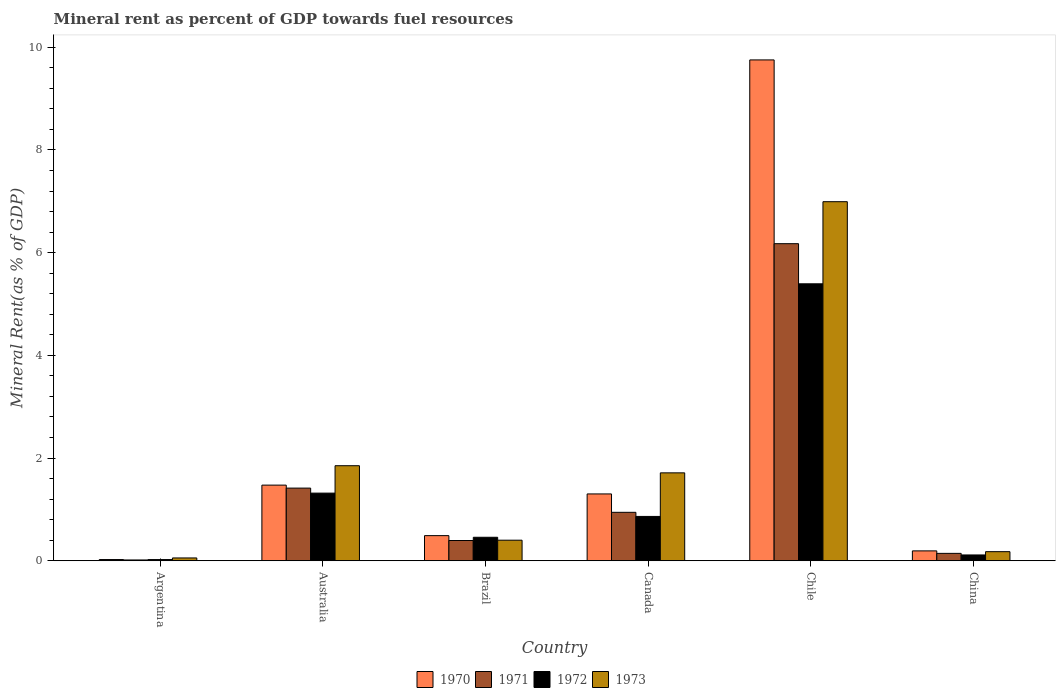Are the number of bars on each tick of the X-axis equal?
Make the answer very short. Yes. How many bars are there on the 2nd tick from the right?
Offer a terse response. 4. In how many cases, is the number of bars for a given country not equal to the number of legend labels?
Make the answer very short. 0. What is the mineral rent in 1971 in Australia?
Offer a very short reply. 1.42. Across all countries, what is the maximum mineral rent in 1972?
Keep it short and to the point. 5.39. Across all countries, what is the minimum mineral rent in 1970?
Your answer should be compact. 0.02. In which country was the mineral rent in 1972 maximum?
Provide a succinct answer. Chile. What is the total mineral rent in 1972 in the graph?
Your response must be concise. 8.17. What is the difference between the mineral rent in 1971 in Brazil and that in China?
Your answer should be compact. 0.25. What is the difference between the mineral rent in 1973 in Canada and the mineral rent in 1972 in Chile?
Give a very brief answer. -3.68. What is the average mineral rent in 1970 per country?
Ensure brevity in your answer.  2.21. What is the difference between the mineral rent of/in 1970 and mineral rent of/in 1973 in Chile?
Your answer should be compact. 2.76. In how many countries, is the mineral rent in 1971 greater than 8 %?
Give a very brief answer. 0. What is the ratio of the mineral rent in 1970 in Argentina to that in China?
Offer a terse response. 0.12. Is the mineral rent in 1970 in Australia less than that in Chile?
Your answer should be compact. Yes. What is the difference between the highest and the second highest mineral rent in 1973?
Provide a succinct answer. 0.14. What is the difference between the highest and the lowest mineral rent in 1971?
Make the answer very short. 6.16. In how many countries, is the mineral rent in 1972 greater than the average mineral rent in 1972 taken over all countries?
Make the answer very short. 1. Is the sum of the mineral rent in 1971 in Brazil and Chile greater than the maximum mineral rent in 1970 across all countries?
Make the answer very short. No. Is it the case that in every country, the sum of the mineral rent in 1973 and mineral rent in 1971 is greater than the sum of mineral rent in 1972 and mineral rent in 1970?
Your answer should be compact. No. What does the 3rd bar from the left in Canada represents?
Provide a short and direct response. 1972. Are all the bars in the graph horizontal?
Your answer should be compact. No. How many countries are there in the graph?
Offer a very short reply. 6. What is the difference between two consecutive major ticks on the Y-axis?
Your response must be concise. 2. Does the graph contain any zero values?
Ensure brevity in your answer.  No. Does the graph contain grids?
Offer a very short reply. No. Where does the legend appear in the graph?
Offer a terse response. Bottom center. What is the title of the graph?
Provide a succinct answer. Mineral rent as percent of GDP towards fuel resources. What is the label or title of the Y-axis?
Make the answer very short. Mineral Rent(as % of GDP). What is the Mineral Rent(as % of GDP) in 1970 in Argentina?
Give a very brief answer. 0.02. What is the Mineral Rent(as % of GDP) of 1971 in Argentina?
Offer a terse response. 0.02. What is the Mineral Rent(as % of GDP) of 1972 in Argentina?
Provide a succinct answer. 0.02. What is the Mineral Rent(as % of GDP) of 1973 in Argentina?
Provide a short and direct response. 0.06. What is the Mineral Rent(as % of GDP) in 1970 in Australia?
Offer a very short reply. 1.47. What is the Mineral Rent(as % of GDP) in 1971 in Australia?
Your answer should be compact. 1.42. What is the Mineral Rent(as % of GDP) of 1972 in Australia?
Give a very brief answer. 1.32. What is the Mineral Rent(as % of GDP) of 1973 in Australia?
Offer a terse response. 1.85. What is the Mineral Rent(as % of GDP) of 1970 in Brazil?
Your answer should be very brief. 0.49. What is the Mineral Rent(as % of GDP) of 1971 in Brazil?
Keep it short and to the point. 0.39. What is the Mineral Rent(as % of GDP) in 1972 in Brazil?
Make the answer very short. 0.46. What is the Mineral Rent(as % of GDP) in 1973 in Brazil?
Your response must be concise. 0.4. What is the Mineral Rent(as % of GDP) of 1970 in Canada?
Ensure brevity in your answer.  1.3. What is the Mineral Rent(as % of GDP) in 1971 in Canada?
Provide a short and direct response. 0.94. What is the Mineral Rent(as % of GDP) of 1972 in Canada?
Your response must be concise. 0.86. What is the Mineral Rent(as % of GDP) of 1973 in Canada?
Your answer should be compact. 1.71. What is the Mineral Rent(as % of GDP) of 1970 in Chile?
Offer a very short reply. 9.75. What is the Mineral Rent(as % of GDP) of 1971 in Chile?
Offer a very short reply. 6.18. What is the Mineral Rent(as % of GDP) in 1972 in Chile?
Keep it short and to the point. 5.39. What is the Mineral Rent(as % of GDP) of 1973 in Chile?
Offer a very short reply. 6.99. What is the Mineral Rent(as % of GDP) in 1970 in China?
Provide a short and direct response. 0.19. What is the Mineral Rent(as % of GDP) of 1971 in China?
Your answer should be very brief. 0.14. What is the Mineral Rent(as % of GDP) in 1972 in China?
Offer a very short reply. 0.11. What is the Mineral Rent(as % of GDP) of 1973 in China?
Give a very brief answer. 0.18. Across all countries, what is the maximum Mineral Rent(as % of GDP) of 1970?
Provide a short and direct response. 9.75. Across all countries, what is the maximum Mineral Rent(as % of GDP) in 1971?
Offer a very short reply. 6.18. Across all countries, what is the maximum Mineral Rent(as % of GDP) of 1972?
Give a very brief answer. 5.39. Across all countries, what is the maximum Mineral Rent(as % of GDP) of 1973?
Your answer should be very brief. 6.99. Across all countries, what is the minimum Mineral Rent(as % of GDP) of 1970?
Offer a very short reply. 0.02. Across all countries, what is the minimum Mineral Rent(as % of GDP) of 1971?
Give a very brief answer. 0.02. Across all countries, what is the minimum Mineral Rent(as % of GDP) in 1972?
Provide a succinct answer. 0.02. Across all countries, what is the minimum Mineral Rent(as % of GDP) in 1973?
Provide a succinct answer. 0.06. What is the total Mineral Rent(as % of GDP) in 1970 in the graph?
Offer a very short reply. 13.24. What is the total Mineral Rent(as % of GDP) in 1971 in the graph?
Make the answer very short. 9.09. What is the total Mineral Rent(as % of GDP) of 1972 in the graph?
Offer a terse response. 8.17. What is the total Mineral Rent(as % of GDP) of 1973 in the graph?
Keep it short and to the point. 11.19. What is the difference between the Mineral Rent(as % of GDP) of 1970 in Argentina and that in Australia?
Your answer should be compact. -1.45. What is the difference between the Mineral Rent(as % of GDP) in 1971 in Argentina and that in Australia?
Your response must be concise. -1.4. What is the difference between the Mineral Rent(as % of GDP) of 1972 in Argentina and that in Australia?
Provide a succinct answer. -1.29. What is the difference between the Mineral Rent(as % of GDP) of 1973 in Argentina and that in Australia?
Your answer should be very brief. -1.8. What is the difference between the Mineral Rent(as % of GDP) of 1970 in Argentina and that in Brazil?
Provide a succinct answer. -0.47. What is the difference between the Mineral Rent(as % of GDP) in 1971 in Argentina and that in Brazil?
Your answer should be very brief. -0.38. What is the difference between the Mineral Rent(as % of GDP) in 1972 in Argentina and that in Brazil?
Offer a very short reply. -0.43. What is the difference between the Mineral Rent(as % of GDP) in 1973 in Argentina and that in Brazil?
Your response must be concise. -0.35. What is the difference between the Mineral Rent(as % of GDP) in 1970 in Argentina and that in Canada?
Ensure brevity in your answer.  -1.28. What is the difference between the Mineral Rent(as % of GDP) in 1971 in Argentina and that in Canada?
Ensure brevity in your answer.  -0.93. What is the difference between the Mineral Rent(as % of GDP) of 1972 in Argentina and that in Canada?
Keep it short and to the point. -0.84. What is the difference between the Mineral Rent(as % of GDP) in 1973 in Argentina and that in Canada?
Make the answer very short. -1.66. What is the difference between the Mineral Rent(as % of GDP) in 1970 in Argentina and that in Chile?
Ensure brevity in your answer.  -9.73. What is the difference between the Mineral Rent(as % of GDP) in 1971 in Argentina and that in Chile?
Offer a terse response. -6.16. What is the difference between the Mineral Rent(as % of GDP) in 1972 in Argentina and that in Chile?
Your answer should be compact. -5.37. What is the difference between the Mineral Rent(as % of GDP) of 1973 in Argentina and that in Chile?
Offer a terse response. -6.94. What is the difference between the Mineral Rent(as % of GDP) of 1970 in Argentina and that in China?
Provide a short and direct response. -0.17. What is the difference between the Mineral Rent(as % of GDP) of 1971 in Argentina and that in China?
Your response must be concise. -0.13. What is the difference between the Mineral Rent(as % of GDP) in 1972 in Argentina and that in China?
Offer a terse response. -0.09. What is the difference between the Mineral Rent(as % of GDP) in 1973 in Argentina and that in China?
Offer a very short reply. -0.12. What is the difference between the Mineral Rent(as % of GDP) of 1971 in Australia and that in Brazil?
Provide a short and direct response. 1.02. What is the difference between the Mineral Rent(as % of GDP) of 1972 in Australia and that in Brazil?
Provide a short and direct response. 0.86. What is the difference between the Mineral Rent(as % of GDP) in 1973 in Australia and that in Brazil?
Your response must be concise. 1.45. What is the difference between the Mineral Rent(as % of GDP) of 1970 in Australia and that in Canada?
Give a very brief answer. 0.17. What is the difference between the Mineral Rent(as % of GDP) in 1971 in Australia and that in Canada?
Provide a short and direct response. 0.47. What is the difference between the Mineral Rent(as % of GDP) of 1972 in Australia and that in Canada?
Offer a very short reply. 0.45. What is the difference between the Mineral Rent(as % of GDP) in 1973 in Australia and that in Canada?
Give a very brief answer. 0.14. What is the difference between the Mineral Rent(as % of GDP) of 1970 in Australia and that in Chile?
Offer a terse response. -8.28. What is the difference between the Mineral Rent(as % of GDP) in 1971 in Australia and that in Chile?
Your response must be concise. -4.76. What is the difference between the Mineral Rent(as % of GDP) of 1972 in Australia and that in Chile?
Keep it short and to the point. -4.08. What is the difference between the Mineral Rent(as % of GDP) of 1973 in Australia and that in Chile?
Provide a short and direct response. -5.14. What is the difference between the Mineral Rent(as % of GDP) in 1970 in Australia and that in China?
Your response must be concise. 1.28. What is the difference between the Mineral Rent(as % of GDP) in 1971 in Australia and that in China?
Provide a succinct answer. 1.27. What is the difference between the Mineral Rent(as % of GDP) of 1972 in Australia and that in China?
Offer a terse response. 1.2. What is the difference between the Mineral Rent(as % of GDP) of 1973 in Australia and that in China?
Your answer should be very brief. 1.67. What is the difference between the Mineral Rent(as % of GDP) in 1970 in Brazil and that in Canada?
Provide a succinct answer. -0.81. What is the difference between the Mineral Rent(as % of GDP) of 1971 in Brazil and that in Canada?
Your answer should be compact. -0.55. What is the difference between the Mineral Rent(as % of GDP) in 1972 in Brazil and that in Canada?
Make the answer very short. -0.41. What is the difference between the Mineral Rent(as % of GDP) in 1973 in Brazil and that in Canada?
Provide a succinct answer. -1.31. What is the difference between the Mineral Rent(as % of GDP) of 1970 in Brazil and that in Chile?
Offer a very short reply. -9.26. What is the difference between the Mineral Rent(as % of GDP) of 1971 in Brazil and that in Chile?
Keep it short and to the point. -5.78. What is the difference between the Mineral Rent(as % of GDP) in 1972 in Brazil and that in Chile?
Ensure brevity in your answer.  -4.94. What is the difference between the Mineral Rent(as % of GDP) in 1973 in Brazil and that in Chile?
Your answer should be very brief. -6.59. What is the difference between the Mineral Rent(as % of GDP) in 1970 in Brazil and that in China?
Your answer should be very brief. 0.3. What is the difference between the Mineral Rent(as % of GDP) in 1971 in Brazil and that in China?
Offer a very short reply. 0.25. What is the difference between the Mineral Rent(as % of GDP) in 1972 in Brazil and that in China?
Keep it short and to the point. 0.34. What is the difference between the Mineral Rent(as % of GDP) in 1973 in Brazil and that in China?
Make the answer very short. 0.22. What is the difference between the Mineral Rent(as % of GDP) in 1970 in Canada and that in Chile?
Offer a terse response. -8.45. What is the difference between the Mineral Rent(as % of GDP) of 1971 in Canada and that in Chile?
Your answer should be compact. -5.23. What is the difference between the Mineral Rent(as % of GDP) in 1972 in Canada and that in Chile?
Offer a very short reply. -4.53. What is the difference between the Mineral Rent(as % of GDP) of 1973 in Canada and that in Chile?
Your response must be concise. -5.28. What is the difference between the Mineral Rent(as % of GDP) in 1970 in Canada and that in China?
Your answer should be compact. 1.11. What is the difference between the Mineral Rent(as % of GDP) of 1971 in Canada and that in China?
Keep it short and to the point. 0.8. What is the difference between the Mineral Rent(as % of GDP) in 1972 in Canada and that in China?
Your answer should be compact. 0.75. What is the difference between the Mineral Rent(as % of GDP) in 1973 in Canada and that in China?
Your response must be concise. 1.53. What is the difference between the Mineral Rent(as % of GDP) of 1970 in Chile and that in China?
Ensure brevity in your answer.  9.56. What is the difference between the Mineral Rent(as % of GDP) of 1971 in Chile and that in China?
Your answer should be compact. 6.03. What is the difference between the Mineral Rent(as % of GDP) in 1972 in Chile and that in China?
Offer a very short reply. 5.28. What is the difference between the Mineral Rent(as % of GDP) in 1973 in Chile and that in China?
Make the answer very short. 6.82. What is the difference between the Mineral Rent(as % of GDP) in 1970 in Argentina and the Mineral Rent(as % of GDP) in 1971 in Australia?
Offer a terse response. -1.39. What is the difference between the Mineral Rent(as % of GDP) of 1970 in Argentina and the Mineral Rent(as % of GDP) of 1972 in Australia?
Offer a terse response. -1.29. What is the difference between the Mineral Rent(as % of GDP) of 1970 in Argentina and the Mineral Rent(as % of GDP) of 1973 in Australia?
Provide a succinct answer. -1.83. What is the difference between the Mineral Rent(as % of GDP) of 1971 in Argentina and the Mineral Rent(as % of GDP) of 1972 in Australia?
Your answer should be very brief. -1.3. What is the difference between the Mineral Rent(as % of GDP) in 1971 in Argentina and the Mineral Rent(as % of GDP) in 1973 in Australia?
Offer a very short reply. -1.84. What is the difference between the Mineral Rent(as % of GDP) of 1972 in Argentina and the Mineral Rent(as % of GDP) of 1973 in Australia?
Provide a succinct answer. -1.83. What is the difference between the Mineral Rent(as % of GDP) of 1970 in Argentina and the Mineral Rent(as % of GDP) of 1971 in Brazil?
Give a very brief answer. -0.37. What is the difference between the Mineral Rent(as % of GDP) in 1970 in Argentina and the Mineral Rent(as % of GDP) in 1972 in Brazil?
Give a very brief answer. -0.43. What is the difference between the Mineral Rent(as % of GDP) of 1970 in Argentina and the Mineral Rent(as % of GDP) of 1973 in Brazil?
Make the answer very short. -0.38. What is the difference between the Mineral Rent(as % of GDP) in 1971 in Argentina and the Mineral Rent(as % of GDP) in 1972 in Brazil?
Provide a short and direct response. -0.44. What is the difference between the Mineral Rent(as % of GDP) of 1971 in Argentina and the Mineral Rent(as % of GDP) of 1973 in Brazil?
Offer a terse response. -0.39. What is the difference between the Mineral Rent(as % of GDP) in 1972 in Argentina and the Mineral Rent(as % of GDP) in 1973 in Brazil?
Provide a succinct answer. -0.38. What is the difference between the Mineral Rent(as % of GDP) in 1970 in Argentina and the Mineral Rent(as % of GDP) in 1971 in Canada?
Offer a terse response. -0.92. What is the difference between the Mineral Rent(as % of GDP) of 1970 in Argentina and the Mineral Rent(as % of GDP) of 1972 in Canada?
Provide a succinct answer. -0.84. What is the difference between the Mineral Rent(as % of GDP) of 1970 in Argentina and the Mineral Rent(as % of GDP) of 1973 in Canada?
Ensure brevity in your answer.  -1.69. What is the difference between the Mineral Rent(as % of GDP) of 1971 in Argentina and the Mineral Rent(as % of GDP) of 1972 in Canada?
Your answer should be compact. -0.85. What is the difference between the Mineral Rent(as % of GDP) in 1971 in Argentina and the Mineral Rent(as % of GDP) in 1973 in Canada?
Keep it short and to the point. -1.7. What is the difference between the Mineral Rent(as % of GDP) of 1972 in Argentina and the Mineral Rent(as % of GDP) of 1973 in Canada?
Make the answer very short. -1.69. What is the difference between the Mineral Rent(as % of GDP) of 1970 in Argentina and the Mineral Rent(as % of GDP) of 1971 in Chile?
Keep it short and to the point. -6.15. What is the difference between the Mineral Rent(as % of GDP) in 1970 in Argentina and the Mineral Rent(as % of GDP) in 1972 in Chile?
Offer a very short reply. -5.37. What is the difference between the Mineral Rent(as % of GDP) of 1970 in Argentina and the Mineral Rent(as % of GDP) of 1973 in Chile?
Provide a succinct answer. -6.97. What is the difference between the Mineral Rent(as % of GDP) in 1971 in Argentina and the Mineral Rent(as % of GDP) in 1972 in Chile?
Your answer should be very brief. -5.38. What is the difference between the Mineral Rent(as % of GDP) in 1971 in Argentina and the Mineral Rent(as % of GDP) in 1973 in Chile?
Your answer should be very brief. -6.98. What is the difference between the Mineral Rent(as % of GDP) in 1972 in Argentina and the Mineral Rent(as % of GDP) in 1973 in Chile?
Provide a short and direct response. -6.97. What is the difference between the Mineral Rent(as % of GDP) of 1970 in Argentina and the Mineral Rent(as % of GDP) of 1971 in China?
Offer a very short reply. -0.12. What is the difference between the Mineral Rent(as % of GDP) in 1970 in Argentina and the Mineral Rent(as % of GDP) in 1972 in China?
Your response must be concise. -0.09. What is the difference between the Mineral Rent(as % of GDP) of 1970 in Argentina and the Mineral Rent(as % of GDP) of 1973 in China?
Keep it short and to the point. -0.15. What is the difference between the Mineral Rent(as % of GDP) in 1971 in Argentina and the Mineral Rent(as % of GDP) in 1972 in China?
Ensure brevity in your answer.  -0.1. What is the difference between the Mineral Rent(as % of GDP) in 1971 in Argentina and the Mineral Rent(as % of GDP) in 1973 in China?
Provide a succinct answer. -0.16. What is the difference between the Mineral Rent(as % of GDP) in 1972 in Argentina and the Mineral Rent(as % of GDP) in 1973 in China?
Your answer should be very brief. -0.15. What is the difference between the Mineral Rent(as % of GDP) in 1970 in Australia and the Mineral Rent(as % of GDP) in 1971 in Brazil?
Ensure brevity in your answer.  1.08. What is the difference between the Mineral Rent(as % of GDP) of 1970 in Australia and the Mineral Rent(as % of GDP) of 1972 in Brazil?
Your answer should be compact. 1.02. What is the difference between the Mineral Rent(as % of GDP) of 1970 in Australia and the Mineral Rent(as % of GDP) of 1973 in Brazil?
Make the answer very short. 1.07. What is the difference between the Mineral Rent(as % of GDP) in 1971 in Australia and the Mineral Rent(as % of GDP) in 1972 in Brazil?
Make the answer very short. 0.96. What is the difference between the Mineral Rent(as % of GDP) of 1971 in Australia and the Mineral Rent(as % of GDP) of 1973 in Brazil?
Ensure brevity in your answer.  1.01. What is the difference between the Mineral Rent(as % of GDP) of 1972 in Australia and the Mineral Rent(as % of GDP) of 1973 in Brazil?
Your answer should be very brief. 0.92. What is the difference between the Mineral Rent(as % of GDP) of 1970 in Australia and the Mineral Rent(as % of GDP) of 1971 in Canada?
Ensure brevity in your answer.  0.53. What is the difference between the Mineral Rent(as % of GDP) in 1970 in Australia and the Mineral Rent(as % of GDP) in 1972 in Canada?
Offer a very short reply. 0.61. What is the difference between the Mineral Rent(as % of GDP) in 1970 in Australia and the Mineral Rent(as % of GDP) in 1973 in Canada?
Make the answer very short. -0.24. What is the difference between the Mineral Rent(as % of GDP) of 1971 in Australia and the Mineral Rent(as % of GDP) of 1972 in Canada?
Your answer should be compact. 0.55. What is the difference between the Mineral Rent(as % of GDP) of 1971 in Australia and the Mineral Rent(as % of GDP) of 1973 in Canada?
Provide a succinct answer. -0.3. What is the difference between the Mineral Rent(as % of GDP) of 1972 in Australia and the Mineral Rent(as % of GDP) of 1973 in Canada?
Ensure brevity in your answer.  -0.39. What is the difference between the Mineral Rent(as % of GDP) in 1970 in Australia and the Mineral Rent(as % of GDP) in 1971 in Chile?
Your answer should be compact. -4.7. What is the difference between the Mineral Rent(as % of GDP) in 1970 in Australia and the Mineral Rent(as % of GDP) in 1972 in Chile?
Your answer should be very brief. -3.92. What is the difference between the Mineral Rent(as % of GDP) of 1970 in Australia and the Mineral Rent(as % of GDP) of 1973 in Chile?
Your answer should be compact. -5.52. What is the difference between the Mineral Rent(as % of GDP) in 1971 in Australia and the Mineral Rent(as % of GDP) in 1972 in Chile?
Offer a very short reply. -3.98. What is the difference between the Mineral Rent(as % of GDP) in 1971 in Australia and the Mineral Rent(as % of GDP) in 1973 in Chile?
Your answer should be very brief. -5.58. What is the difference between the Mineral Rent(as % of GDP) in 1972 in Australia and the Mineral Rent(as % of GDP) in 1973 in Chile?
Your answer should be very brief. -5.68. What is the difference between the Mineral Rent(as % of GDP) in 1970 in Australia and the Mineral Rent(as % of GDP) in 1971 in China?
Your answer should be very brief. 1.33. What is the difference between the Mineral Rent(as % of GDP) in 1970 in Australia and the Mineral Rent(as % of GDP) in 1972 in China?
Ensure brevity in your answer.  1.36. What is the difference between the Mineral Rent(as % of GDP) of 1970 in Australia and the Mineral Rent(as % of GDP) of 1973 in China?
Offer a terse response. 1.3. What is the difference between the Mineral Rent(as % of GDP) in 1971 in Australia and the Mineral Rent(as % of GDP) in 1972 in China?
Make the answer very short. 1.3. What is the difference between the Mineral Rent(as % of GDP) of 1971 in Australia and the Mineral Rent(as % of GDP) of 1973 in China?
Ensure brevity in your answer.  1.24. What is the difference between the Mineral Rent(as % of GDP) in 1972 in Australia and the Mineral Rent(as % of GDP) in 1973 in China?
Offer a very short reply. 1.14. What is the difference between the Mineral Rent(as % of GDP) of 1970 in Brazil and the Mineral Rent(as % of GDP) of 1971 in Canada?
Offer a very short reply. -0.45. What is the difference between the Mineral Rent(as % of GDP) in 1970 in Brazil and the Mineral Rent(as % of GDP) in 1972 in Canada?
Provide a succinct answer. -0.37. What is the difference between the Mineral Rent(as % of GDP) in 1970 in Brazil and the Mineral Rent(as % of GDP) in 1973 in Canada?
Your response must be concise. -1.22. What is the difference between the Mineral Rent(as % of GDP) in 1971 in Brazil and the Mineral Rent(as % of GDP) in 1972 in Canada?
Your response must be concise. -0.47. What is the difference between the Mineral Rent(as % of GDP) in 1971 in Brazil and the Mineral Rent(as % of GDP) in 1973 in Canada?
Keep it short and to the point. -1.32. What is the difference between the Mineral Rent(as % of GDP) in 1972 in Brazil and the Mineral Rent(as % of GDP) in 1973 in Canada?
Offer a terse response. -1.25. What is the difference between the Mineral Rent(as % of GDP) of 1970 in Brazil and the Mineral Rent(as % of GDP) of 1971 in Chile?
Keep it short and to the point. -5.69. What is the difference between the Mineral Rent(as % of GDP) of 1970 in Brazil and the Mineral Rent(as % of GDP) of 1972 in Chile?
Provide a short and direct response. -4.9. What is the difference between the Mineral Rent(as % of GDP) of 1970 in Brazil and the Mineral Rent(as % of GDP) of 1973 in Chile?
Your answer should be compact. -6.5. What is the difference between the Mineral Rent(as % of GDP) in 1971 in Brazil and the Mineral Rent(as % of GDP) in 1972 in Chile?
Provide a short and direct response. -5. What is the difference between the Mineral Rent(as % of GDP) of 1971 in Brazil and the Mineral Rent(as % of GDP) of 1973 in Chile?
Your response must be concise. -6.6. What is the difference between the Mineral Rent(as % of GDP) of 1972 in Brazil and the Mineral Rent(as % of GDP) of 1973 in Chile?
Keep it short and to the point. -6.54. What is the difference between the Mineral Rent(as % of GDP) in 1970 in Brazil and the Mineral Rent(as % of GDP) in 1971 in China?
Ensure brevity in your answer.  0.35. What is the difference between the Mineral Rent(as % of GDP) in 1970 in Brazil and the Mineral Rent(as % of GDP) in 1972 in China?
Your answer should be very brief. 0.38. What is the difference between the Mineral Rent(as % of GDP) of 1970 in Brazil and the Mineral Rent(as % of GDP) of 1973 in China?
Make the answer very short. 0.31. What is the difference between the Mineral Rent(as % of GDP) in 1971 in Brazil and the Mineral Rent(as % of GDP) in 1972 in China?
Keep it short and to the point. 0.28. What is the difference between the Mineral Rent(as % of GDP) in 1971 in Brazil and the Mineral Rent(as % of GDP) in 1973 in China?
Provide a succinct answer. 0.22. What is the difference between the Mineral Rent(as % of GDP) of 1972 in Brazil and the Mineral Rent(as % of GDP) of 1973 in China?
Give a very brief answer. 0.28. What is the difference between the Mineral Rent(as % of GDP) in 1970 in Canada and the Mineral Rent(as % of GDP) in 1971 in Chile?
Your answer should be compact. -4.87. What is the difference between the Mineral Rent(as % of GDP) in 1970 in Canada and the Mineral Rent(as % of GDP) in 1972 in Chile?
Your answer should be compact. -4.09. What is the difference between the Mineral Rent(as % of GDP) in 1970 in Canada and the Mineral Rent(as % of GDP) in 1973 in Chile?
Your response must be concise. -5.69. What is the difference between the Mineral Rent(as % of GDP) of 1971 in Canada and the Mineral Rent(as % of GDP) of 1972 in Chile?
Provide a short and direct response. -4.45. What is the difference between the Mineral Rent(as % of GDP) of 1971 in Canada and the Mineral Rent(as % of GDP) of 1973 in Chile?
Your answer should be compact. -6.05. What is the difference between the Mineral Rent(as % of GDP) of 1972 in Canada and the Mineral Rent(as % of GDP) of 1973 in Chile?
Offer a very short reply. -6.13. What is the difference between the Mineral Rent(as % of GDP) of 1970 in Canada and the Mineral Rent(as % of GDP) of 1971 in China?
Your answer should be very brief. 1.16. What is the difference between the Mineral Rent(as % of GDP) of 1970 in Canada and the Mineral Rent(as % of GDP) of 1972 in China?
Provide a short and direct response. 1.19. What is the difference between the Mineral Rent(as % of GDP) of 1970 in Canada and the Mineral Rent(as % of GDP) of 1973 in China?
Offer a very short reply. 1.12. What is the difference between the Mineral Rent(as % of GDP) in 1971 in Canada and the Mineral Rent(as % of GDP) in 1972 in China?
Provide a short and direct response. 0.83. What is the difference between the Mineral Rent(as % of GDP) in 1971 in Canada and the Mineral Rent(as % of GDP) in 1973 in China?
Make the answer very short. 0.77. What is the difference between the Mineral Rent(as % of GDP) of 1972 in Canada and the Mineral Rent(as % of GDP) of 1973 in China?
Provide a succinct answer. 0.69. What is the difference between the Mineral Rent(as % of GDP) of 1970 in Chile and the Mineral Rent(as % of GDP) of 1971 in China?
Your answer should be compact. 9.61. What is the difference between the Mineral Rent(as % of GDP) of 1970 in Chile and the Mineral Rent(as % of GDP) of 1972 in China?
Offer a terse response. 9.64. What is the difference between the Mineral Rent(as % of GDP) in 1970 in Chile and the Mineral Rent(as % of GDP) in 1973 in China?
Give a very brief answer. 9.58. What is the difference between the Mineral Rent(as % of GDP) in 1971 in Chile and the Mineral Rent(as % of GDP) in 1972 in China?
Your response must be concise. 6.06. What is the difference between the Mineral Rent(as % of GDP) of 1971 in Chile and the Mineral Rent(as % of GDP) of 1973 in China?
Offer a very short reply. 6. What is the difference between the Mineral Rent(as % of GDP) of 1972 in Chile and the Mineral Rent(as % of GDP) of 1973 in China?
Your answer should be very brief. 5.22. What is the average Mineral Rent(as % of GDP) in 1970 per country?
Offer a very short reply. 2.21. What is the average Mineral Rent(as % of GDP) in 1971 per country?
Your answer should be compact. 1.51. What is the average Mineral Rent(as % of GDP) of 1972 per country?
Make the answer very short. 1.36. What is the average Mineral Rent(as % of GDP) in 1973 per country?
Give a very brief answer. 1.86. What is the difference between the Mineral Rent(as % of GDP) of 1970 and Mineral Rent(as % of GDP) of 1971 in Argentina?
Your answer should be very brief. 0.01. What is the difference between the Mineral Rent(as % of GDP) in 1970 and Mineral Rent(as % of GDP) in 1972 in Argentina?
Give a very brief answer. 0. What is the difference between the Mineral Rent(as % of GDP) in 1970 and Mineral Rent(as % of GDP) in 1973 in Argentina?
Your answer should be compact. -0.03. What is the difference between the Mineral Rent(as % of GDP) of 1971 and Mineral Rent(as % of GDP) of 1972 in Argentina?
Your answer should be very brief. -0.01. What is the difference between the Mineral Rent(as % of GDP) of 1971 and Mineral Rent(as % of GDP) of 1973 in Argentina?
Offer a terse response. -0.04. What is the difference between the Mineral Rent(as % of GDP) of 1972 and Mineral Rent(as % of GDP) of 1973 in Argentina?
Ensure brevity in your answer.  -0.03. What is the difference between the Mineral Rent(as % of GDP) of 1970 and Mineral Rent(as % of GDP) of 1971 in Australia?
Keep it short and to the point. 0.06. What is the difference between the Mineral Rent(as % of GDP) in 1970 and Mineral Rent(as % of GDP) in 1972 in Australia?
Offer a terse response. 0.16. What is the difference between the Mineral Rent(as % of GDP) of 1970 and Mineral Rent(as % of GDP) of 1973 in Australia?
Provide a short and direct response. -0.38. What is the difference between the Mineral Rent(as % of GDP) of 1971 and Mineral Rent(as % of GDP) of 1972 in Australia?
Give a very brief answer. 0.1. What is the difference between the Mineral Rent(as % of GDP) of 1971 and Mineral Rent(as % of GDP) of 1973 in Australia?
Your response must be concise. -0.44. What is the difference between the Mineral Rent(as % of GDP) in 1972 and Mineral Rent(as % of GDP) in 1973 in Australia?
Your response must be concise. -0.53. What is the difference between the Mineral Rent(as % of GDP) of 1970 and Mineral Rent(as % of GDP) of 1971 in Brazil?
Ensure brevity in your answer.  0.1. What is the difference between the Mineral Rent(as % of GDP) in 1970 and Mineral Rent(as % of GDP) in 1972 in Brazil?
Keep it short and to the point. 0.03. What is the difference between the Mineral Rent(as % of GDP) in 1970 and Mineral Rent(as % of GDP) in 1973 in Brazil?
Give a very brief answer. 0.09. What is the difference between the Mineral Rent(as % of GDP) in 1971 and Mineral Rent(as % of GDP) in 1972 in Brazil?
Make the answer very short. -0.06. What is the difference between the Mineral Rent(as % of GDP) in 1971 and Mineral Rent(as % of GDP) in 1973 in Brazil?
Give a very brief answer. -0.01. What is the difference between the Mineral Rent(as % of GDP) of 1972 and Mineral Rent(as % of GDP) of 1973 in Brazil?
Provide a short and direct response. 0.06. What is the difference between the Mineral Rent(as % of GDP) in 1970 and Mineral Rent(as % of GDP) in 1971 in Canada?
Give a very brief answer. 0.36. What is the difference between the Mineral Rent(as % of GDP) in 1970 and Mineral Rent(as % of GDP) in 1972 in Canada?
Your answer should be very brief. 0.44. What is the difference between the Mineral Rent(as % of GDP) in 1970 and Mineral Rent(as % of GDP) in 1973 in Canada?
Make the answer very short. -0.41. What is the difference between the Mineral Rent(as % of GDP) of 1971 and Mineral Rent(as % of GDP) of 1972 in Canada?
Provide a succinct answer. 0.08. What is the difference between the Mineral Rent(as % of GDP) of 1971 and Mineral Rent(as % of GDP) of 1973 in Canada?
Keep it short and to the point. -0.77. What is the difference between the Mineral Rent(as % of GDP) of 1972 and Mineral Rent(as % of GDP) of 1973 in Canada?
Make the answer very short. -0.85. What is the difference between the Mineral Rent(as % of GDP) of 1970 and Mineral Rent(as % of GDP) of 1971 in Chile?
Give a very brief answer. 3.58. What is the difference between the Mineral Rent(as % of GDP) of 1970 and Mineral Rent(as % of GDP) of 1972 in Chile?
Make the answer very short. 4.36. What is the difference between the Mineral Rent(as % of GDP) in 1970 and Mineral Rent(as % of GDP) in 1973 in Chile?
Offer a terse response. 2.76. What is the difference between the Mineral Rent(as % of GDP) of 1971 and Mineral Rent(as % of GDP) of 1972 in Chile?
Give a very brief answer. 0.78. What is the difference between the Mineral Rent(as % of GDP) in 1971 and Mineral Rent(as % of GDP) in 1973 in Chile?
Your answer should be compact. -0.82. What is the difference between the Mineral Rent(as % of GDP) in 1972 and Mineral Rent(as % of GDP) in 1973 in Chile?
Ensure brevity in your answer.  -1.6. What is the difference between the Mineral Rent(as % of GDP) of 1970 and Mineral Rent(as % of GDP) of 1971 in China?
Keep it short and to the point. 0.05. What is the difference between the Mineral Rent(as % of GDP) in 1970 and Mineral Rent(as % of GDP) in 1972 in China?
Make the answer very short. 0.08. What is the difference between the Mineral Rent(as % of GDP) in 1970 and Mineral Rent(as % of GDP) in 1973 in China?
Make the answer very short. 0.02. What is the difference between the Mineral Rent(as % of GDP) of 1971 and Mineral Rent(as % of GDP) of 1972 in China?
Make the answer very short. 0.03. What is the difference between the Mineral Rent(as % of GDP) of 1971 and Mineral Rent(as % of GDP) of 1973 in China?
Give a very brief answer. -0.03. What is the difference between the Mineral Rent(as % of GDP) in 1972 and Mineral Rent(as % of GDP) in 1973 in China?
Your response must be concise. -0.06. What is the ratio of the Mineral Rent(as % of GDP) in 1970 in Argentina to that in Australia?
Give a very brief answer. 0.02. What is the ratio of the Mineral Rent(as % of GDP) of 1971 in Argentina to that in Australia?
Provide a succinct answer. 0.01. What is the ratio of the Mineral Rent(as % of GDP) in 1972 in Argentina to that in Australia?
Offer a very short reply. 0.02. What is the ratio of the Mineral Rent(as % of GDP) in 1973 in Argentina to that in Australia?
Offer a very short reply. 0.03. What is the ratio of the Mineral Rent(as % of GDP) of 1970 in Argentina to that in Brazil?
Your response must be concise. 0.05. What is the ratio of the Mineral Rent(as % of GDP) in 1971 in Argentina to that in Brazil?
Offer a very short reply. 0.04. What is the ratio of the Mineral Rent(as % of GDP) of 1972 in Argentina to that in Brazil?
Make the answer very short. 0.05. What is the ratio of the Mineral Rent(as % of GDP) in 1973 in Argentina to that in Brazil?
Your response must be concise. 0.14. What is the ratio of the Mineral Rent(as % of GDP) in 1970 in Argentina to that in Canada?
Your answer should be very brief. 0.02. What is the ratio of the Mineral Rent(as % of GDP) in 1971 in Argentina to that in Canada?
Make the answer very short. 0.02. What is the ratio of the Mineral Rent(as % of GDP) in 1972 in Argentina to that in Canada?
Ensure brevity in your answer.  0.03. What is the ratio of the Mineral Rent(as % of GDP) in 1973 in Argentina to that in Canada?
Your response must be concise. 0.03. What is the ratio of the Mineral Rent(as % of GDP) of 1970 in Argentina to that in Chile?
Keep it short and to the point. 0. What is the ratio of the Mineral Rent(as % of GDP) of 1971 in Argentina to that in Chile?
Give a very brief answer. 0. What is the ratio of the Mineral Rent(as % of GDP) in 1972 in Argentina to that in Chile?
Provide a short and direct response. 0. What is the ratio of the Mineral Rent(as % of GDP) of 1973 in Argentina to that in Chile?
Provide a succinct answer. 0.01. What is the ratio of the Mineral Rent(as % of GDP) in 1970 in Argentina to that in China?
Provide a succinct answer. 0.12. What is the ratio of the Mineral Rent(as % of GDP) of 1971 in Argentina to that in China?
Offer a terse response. 0.11. What is the ratio of the Mineral Rent(as % of GDP) in 1972 in Argentina to that in China?
Provide a short and direct response. 0.21. What is the ratio of the Mineral Rent(as % of GDP) in 1973 in Argentina to that in China?
Your answer should be compact. 0.31. What is the ratio of the Mineral Rent(as % of GDP) in 1970 in Australia to that in Brazil?
Offer a terse response. 3.01. What is the ratio of the Mineral Rent(as % of GDP) of 1971 in Australia to that in Brazil?
Keep it short and to the point. 3.59. What is the ratio of the Mineral Rent(as % of GDP) of 1972 in Australia to that in Brazil?
Provide a short and direct response. 2.88. What is the ratio of the Mineral Rent(as % of GDP) in 1973 in Australia to that in Brazil?
Provide a succinct answer. 4.62. What is the ratio of the Mineral Rent(as % of GDP) of 1970 in Australia to that in Canada?
Give a very brief answer. 1.13. What is the ratio of the Mineral Rent(as % of GDP) in 1971 in Australia to that in Canada?
Provide a succinct answer. 1.5. What is the ratio of the Mineral Rent(as % of GDP) in 1972 in Australia to that in Canada?
Provide a short and direct response. 1.53. What is the ratio of the Mineral Rent(as % of GDP) of 1973 in Australia to that in Canada?
Give a very brief answer. 1.08. What is the ratio of the Mineral Rent(as % of GDP) of 1970 in Australia to that in Chile?
Your answer should be compact. 0.15. What is the ratio of the Mineral Rent(as % of GDP) in 1971 in Australia to that in Chile?
Offer a terse response. 0.23. What is the ratio of the Mineral Rent(as % of GDP) of 1972 in Australia to that in Chile?
Provide a short and direct response. 0.24. What is the ratio of the Mineral Rent(as % of GDP) in 1973 in Australia to that in Chile?
Offer a very short reply. 0.26. What is the ratio of the Mineral Rent(as % of GDP) in 1970 in Australia to that in China?
Your answer should be very brief. 7.65. What is the ratio of the Mineral Rent(as % of GDP) in 1971 in Australia to that in China?
Provide a succinct answer. 9.81. What is the ratio of the Mineral Rent(as % of GDP) of 1972 in Australia to that in China?
Keep it short and to the point. 11.62. What is the ratio of the Mineral Rent(as % of GDP) in 1973 in Australia to that in China?
Give a very brief answer. 10.43. What is the ratio of the Mineral Rent(as % of GDP) of 1970 in Brazil to that in Canada?
Your answer should be compact. 0.38. What is the ratio of the Mineral Rent(as % of GDP) of 1971 in Brazil to that in Canada?
Give a very brief answer. 0.42. What is the ratio of the Mineral Rent(as % of GDP) of 1972 in Brazil to that in Canada?
Give a very brief answer. 0.53. What is the ratio of the Mineral Rent(as % of GDP) in 1973 in Brazil to that in Canada?
Provide a succinct answer. 0.23. What is the ratio of the Mineral Rent(as % of GDP) of 1970 in Brazil to that in Chile?
Offer a very short reply. 0.05. What is the ratio of the Mineral Rent(as % of GDP) of 1971 in Brazil to that in Chile?
Give a very brief answer. 0.06. What is the ratio of the Mineral Rent(as % of GDP) in 1972 in Brazil to that in Chile?
Make the answer very short. 0.08. What is the ratio of the Mineral Rent(as % of GDP) in 1973 in Brazil to that in Chile?
Provide a succinct answer. 0.06. What is the ratio of the Mineral Rent(as % of GDP) in 1970 in Brazil to that in China?
Keep it short and to the point. 2.54. What is the ratio of the Mineral Rent(as % of GDP) of 1971 in Brazil to that in China?
Provide a short and direct response. 2.74. What is the ratio of the Mineral Rent(as % of GDP) of 1972 in Brazil to that in China?
Offer a very short reply. 4.03. What is the ratio of the Mineral Rent(as % of GDP) of 1973 in Brazil to that in China?
Make the answer very short. 2.26. What is the ratio of the Mineral Rent(as % of GDP) of 1970 in Canada to that in Chile?
Offer a very short reply. 0.13. What is the ratio of the Mineral Rent(as % of GDP) in 1971 in Canada to that in Chile?
Provide a succinct answer. 0.15. What is the ratio of the Mineral Rent(as % of GDP) in 1972 in Canada to that in Chile?
Give a very brief answer. 0.16. What is the ratio of the Mineral Rent(as % of GDP) of 1973 in Canada to that in Chile?
Your response must be concise. 0.24. What is the ratio of the Mineral Rent(as % of GDP) of 1970 in Canada to that in China?
Your response must be concise. 6.76. What is the ratio of the Mineral Rent(as % of GDP) of 1971 in Canada to that in China?
Keep it short and to the point. 6.54. What is the ratio of the Mineral Rent(as % of GDP) of 1972 in Canada to that in China?
Make the answer very short. 7.61. What is the ratio of the Mineral Rent(as % of GDP) of 1973 in Canada to that in China?
Your response must be concise. 9.65. What is the ratio of the Mineral Rent(as % of GDP) in 1970 in Chile to that in China?
Offer a terse response. 50.65. What is the ratio of the Mineral Rent(as % of GDP) in 1971 in Chile to that in China?
Offer a very short reply. 42.82. What is the ratio of the Mineral Rent(as % of GDP) of 1972 in Chile to that in China?
Provide a succinct answer. 47.55. What is the ratio of the Mineral Rent(as % of GDP) of 1973 in Chile to that in China?
Offer a very short reply. 39.41. What is the difference between the highest and the second highest Mineral Rent(as % of GDP) of 1970?
Your response must be concise. 8.28. What is the difference between the highest and the second highest Mineral Rent(as % of GDP) of 1971?
Keep it short and to the point. 4.76. What is the difference between the highest and the second highest Mineral Rent(as % of GDP) of 1972?
Your answer should be compact. 4.08. What is the difference between the highest and the second highest Mineral Rent(as % of GDP) of 1973?
Give a very brief answer. 5.14. What is the difference between the highest and the lowest Mineral Rent(as % of GDP) of 1970?
Provide a short and direct response. 9.73. What is the difference between the highest and the lowest Mineral Rent(as % of GDP) in 1971?
Your response must be concise. 6.16. What is the difference between the highest and the lowest Mineral Rent(as % of GDP) in 1972?
Offer a very short reply. 5.37. What is the difference between the highest and the lowest Mineral Rent(as % of GDP) of 1973?
Ensure brevity in your answer.  6.94. 